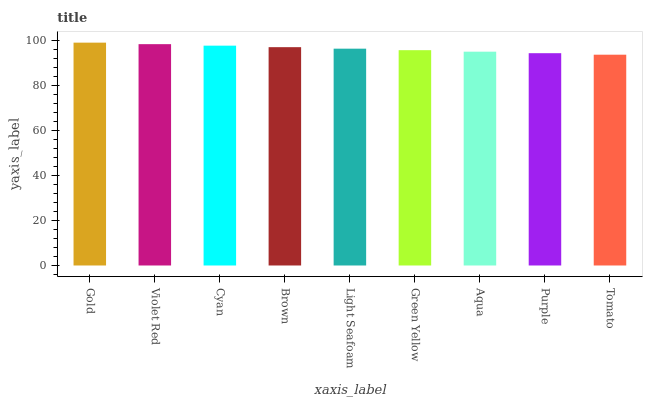Is Tomato the minimum?
Answer yes or no. Yes. Is Gold the maximum?
Answer yes or no. Yes. Is Violet Red the minimum?
Answer yes or no. No. Is Violet Red the maximum?
Answer yes or no. No. Is Gold greater than Violet Red?
Answer yes or no. Yes. Is Violet Red less than Gold?
Answer yes or no. Yes. Is Violet Red greater than Gold?
Answer yes or no. No. Is Gold less than Violet Red?
Answer yes or no. No. Is Light Seafoam the high median?
Answer yes or no. Yes. Is Light Seafoam the low median?
Answer yes or no. Yes. Is Cyan the high median?
Answer yes or no. No. Is Purple the low median?
Answer yes or no. No. 